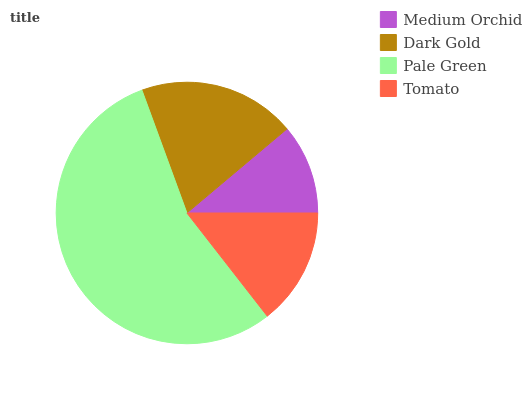Is Medium Orchid the minimum?
Answer yes or no. Yes. Is Pale Green the maximum?
Answer yes or no. Yes. Is Dark Gold the minimum?
Answer yes or no. No. Is Dark Gold the maximum?
Answer yes or no. No. Is Dark Gold greater than Medium Orchid?
Answer yes or no. Yes. Is Medium Orchid less than Dark Gold?
Answer yes or no. Yes. Is Medium Orchid greater than Dark Gold?
Answer yes or no. No. Is Dark Gold less than Medium Orchid?
Answer yes or no. No. Is Dark Gold the high median?
Answer yes or no. Yes. Is Tomato the low median?
Answer yes or no. Yes. Is Tomato the high median?
Answer yes or no. No. Is Dark Gold the low median?
Answer yes or no. No. 